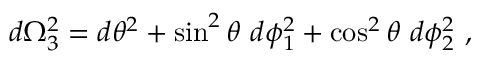<formula> <loc_0><loc_0><loc_500><loc_500>d \Omega _ { 3 } ^ { 2 } = d \theta ^ { 2 } + \sin ^ { 2 } \theta d \phi _ { 1 } ^ { 2 } + \cos ^ { 2 } \theta d \phi _ { 2 } ^ { 2 } \ ,</formula> 